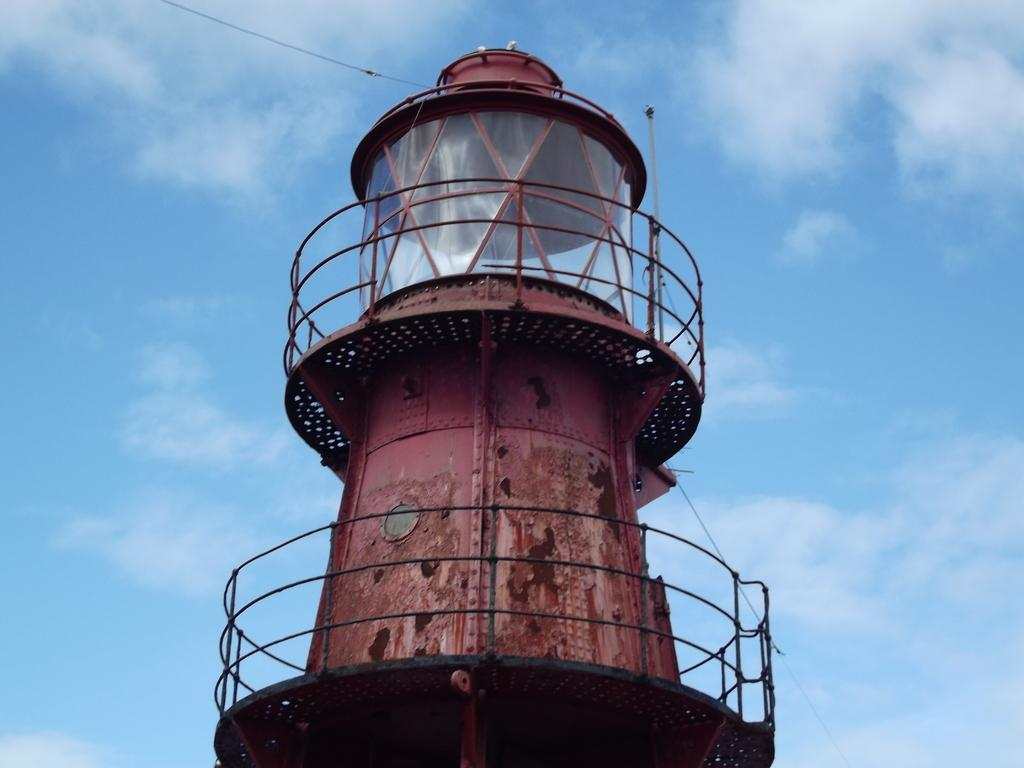What is the main structure in the image? There is a lighthouse in the image. What feature can be seen on the lighthouse? The lighthouse has railings. What can be seen in the background of the image? There is sky visible in the background of the image. What type of weather can be inferred from the image? Clouds are present in the sky, suggesting a partly cloudy day. What type of alarm is ringing during the dinner scene in the image? There is no dinner scene or alarm present in the image; it features a lighthouse with railings and a sky with clouds. 